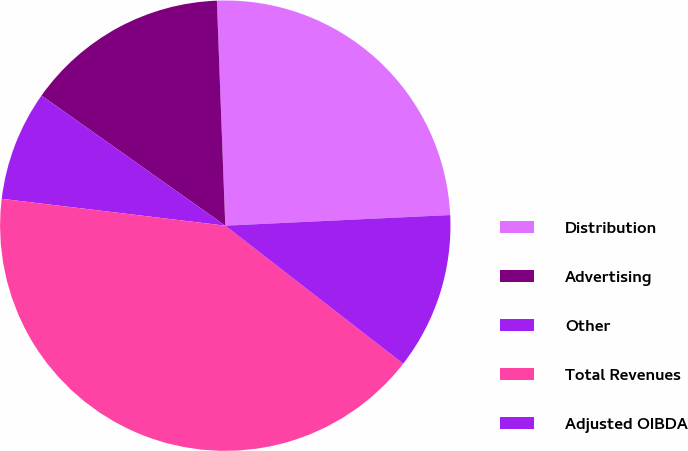Convert chart. <chart><loc_0><loc_0><loc_500><loc_500><pie_chart><fcel>Distribution<fcel>Advertising<fcel>Other<fcel>Total Revenues<fcel>Adjusted OIBDA<nl><fcel>24.84%<fcel>14.6%<fcel>7.9%<fcel>41.4%<fcel>11.25%<nl></chart> 